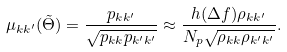Convert formula to latex. <formula><loc_0><loc_0><loc_500><loc_500>\mu _ { k k ^ { \prime } } ( \tilde { \Theta } ) = \frac { p _ { k k ^ { \prime } } } { \sqrt { p _ { k k } p _ { k ^ { \prime } k ^ { \prime } } } } \approx \frac { h ( \Delta f ) \rho _ { k k ^ { \prime } } } { N _ { p } \sqrt { \rho _ { k k } \rho _ { k ^ { \prime } k ^ { \prime } } } } .</formula> 